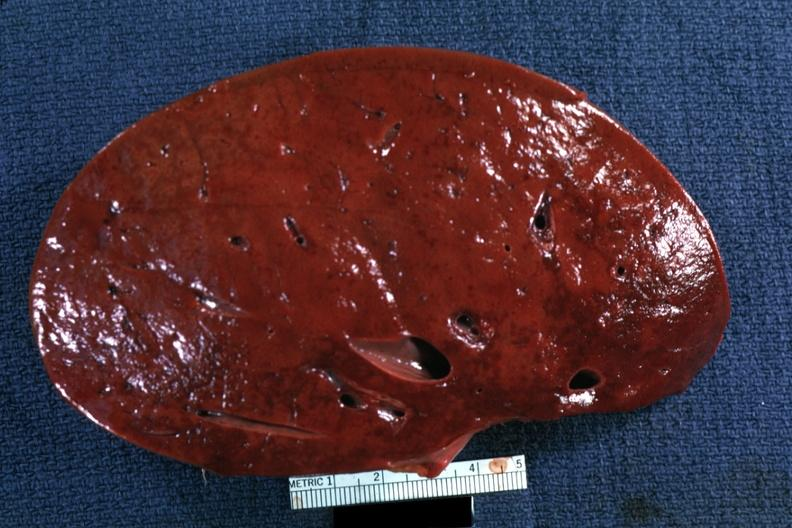what is present?
Answer the question using a single word or phrase. Hematologic 